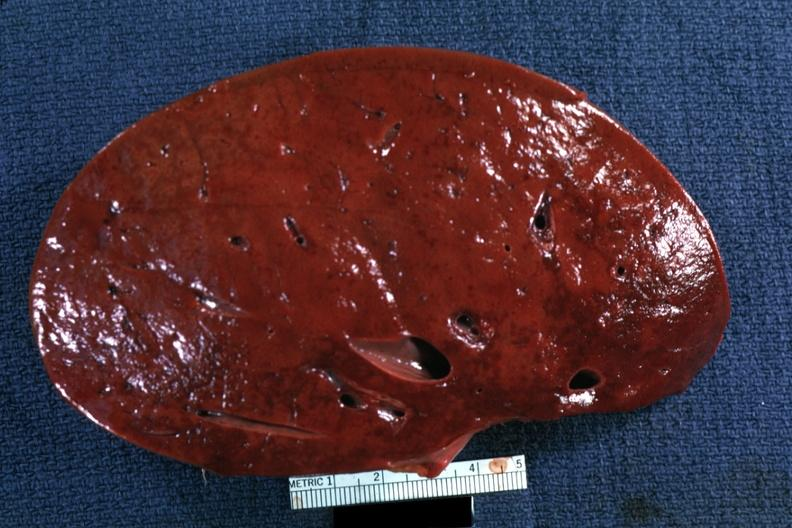what is present?
Answer the question using a single word or phrase. Hematologic 